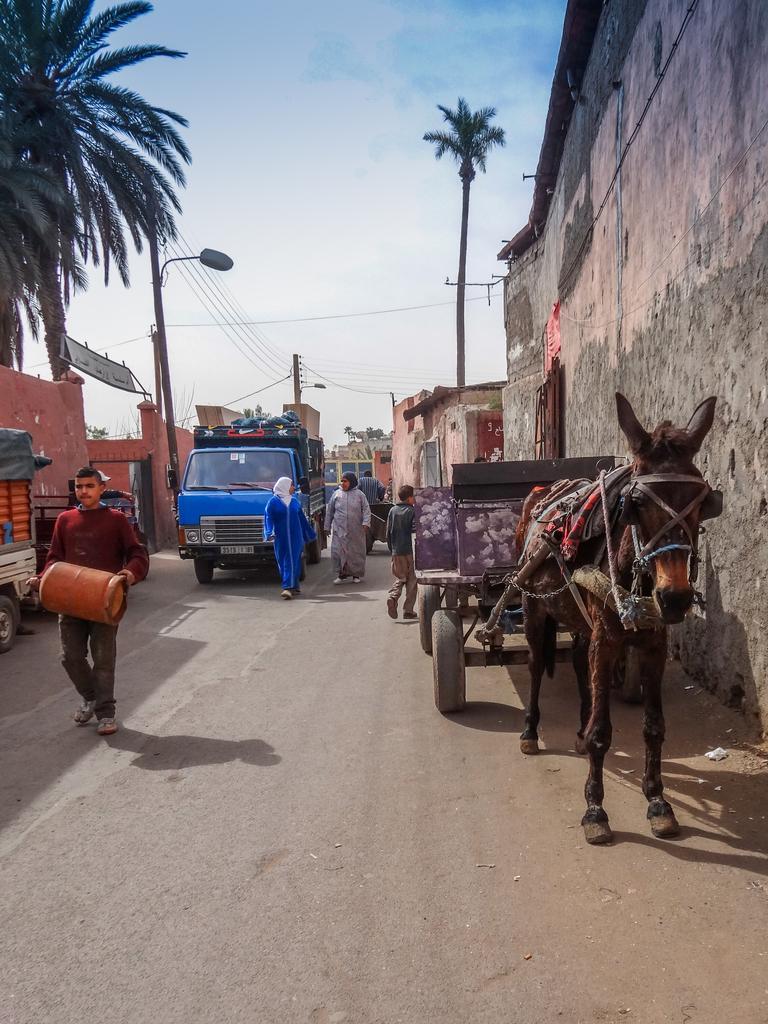Describe this image in one or two sentences. The picture is taken on the street. In the foreground of the picture there are vehicles, cart, people and other objects. On the right there are houses and a palm tree. On the left there are building, street light and a palm tree. In the center of the background there are are houses, cables and current pole. Sky is sunny. 